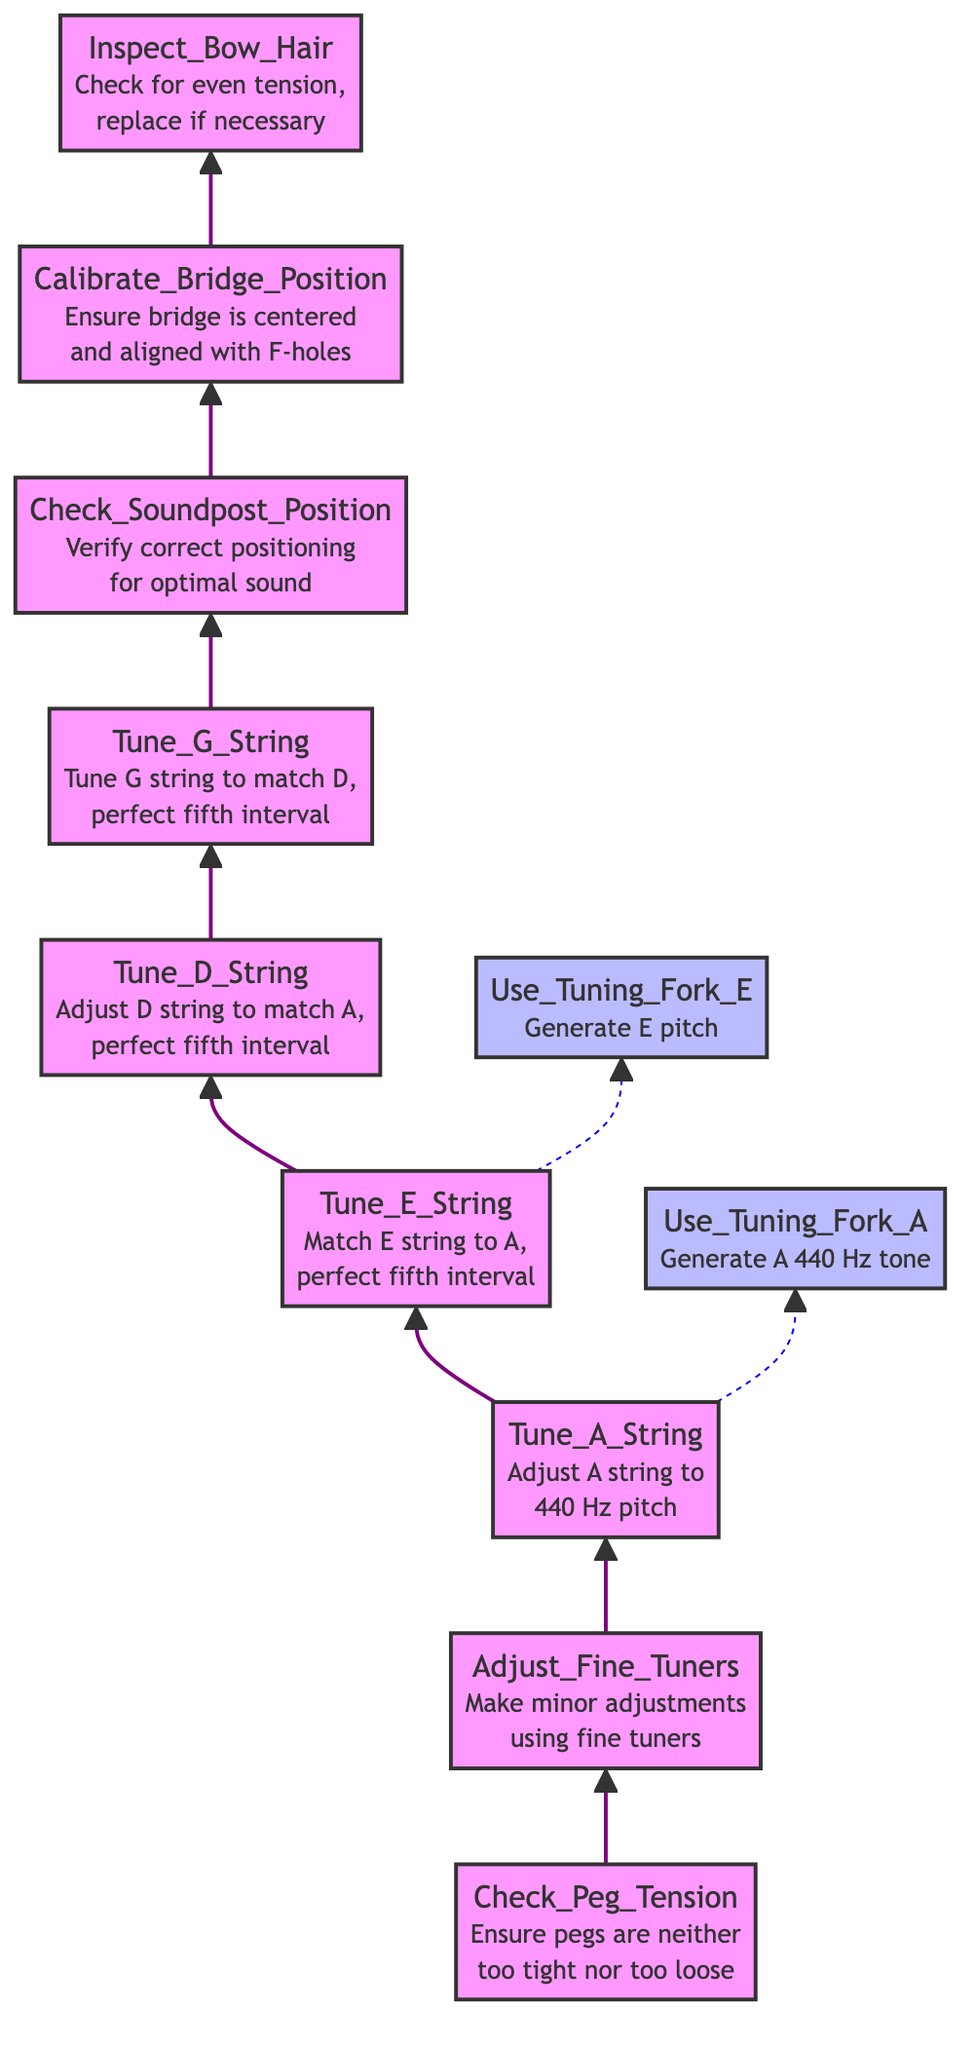What is the first step in the tuning process? The diagram indicates that the first step is "Check Peg Tension," which occurs at the bottom of the flowchart. This step is essential for ensuring stable tuning of the violin.
Answer: Check Peg Tension How many helper functions are present in the diagram? By reviewing the diagram, there are two helper functions: "Use Tuning Fork A" and "Use Tuning Fork E." These functions support the tuning process by generating specific pitches for reference.
Answer: 2 What pitch should the A string be tuned to? According to the diagram, the A string must be adjusted to the standard pitch of 440 Hz, as specified in the "Tune A String" step.
Answer: 440 Hz In which step is the soundpost position checked? The diagram shows that the sound post position is checked after tuning the G string, specifically in the "Check Soundpost Position" step. This step is crucial for the overall sound quality of the instrument.
Answer: Check Soundpost Position What is the relationship between tuning the E string and using a helper function? Observing the diagram, the "Tune E String" step includes the use of the helper function "Use Tuning Fork E." This indicates that the E string is matched to the A string pitch generated by the tuning fork to achieve a perfect fifth interval.
Answer: Use Tuning Fork E Which steps come before inspecting the bow hair? The steps preceding "Inspect Bow Hair" are "Calibrate Bridge Position" and "Check Soundpost Position." The flowchart illustrates a sequence where sound adjustments are made before finalizing bow maintenance.
Answer: Calibrate Bridge Position, Check Soundpost Position Which string is tuned last in the sequence? In the sequence outlined in the diagram, the last string tuned is the G string, as indicated just before checking the sound post position.
Answer: Tune G String What does the adjustment of the fine tuners entail? The diagram describes "Adjust Fine Tuners" as making minor tuning adjustments for precision, allowing for finer control over pitch compared to just using the pegs.
Answer: Make minor adjustments using fine tuners What must be verified before calibrating the bridge position? Before moving on to "Calibrate Bridge Position," it's essential to verify the correct positioning of the sound post, as indicated in the flowchart. This ensures optimal sound quality before adjusting other components.
Answer: Check Soundpost Position 